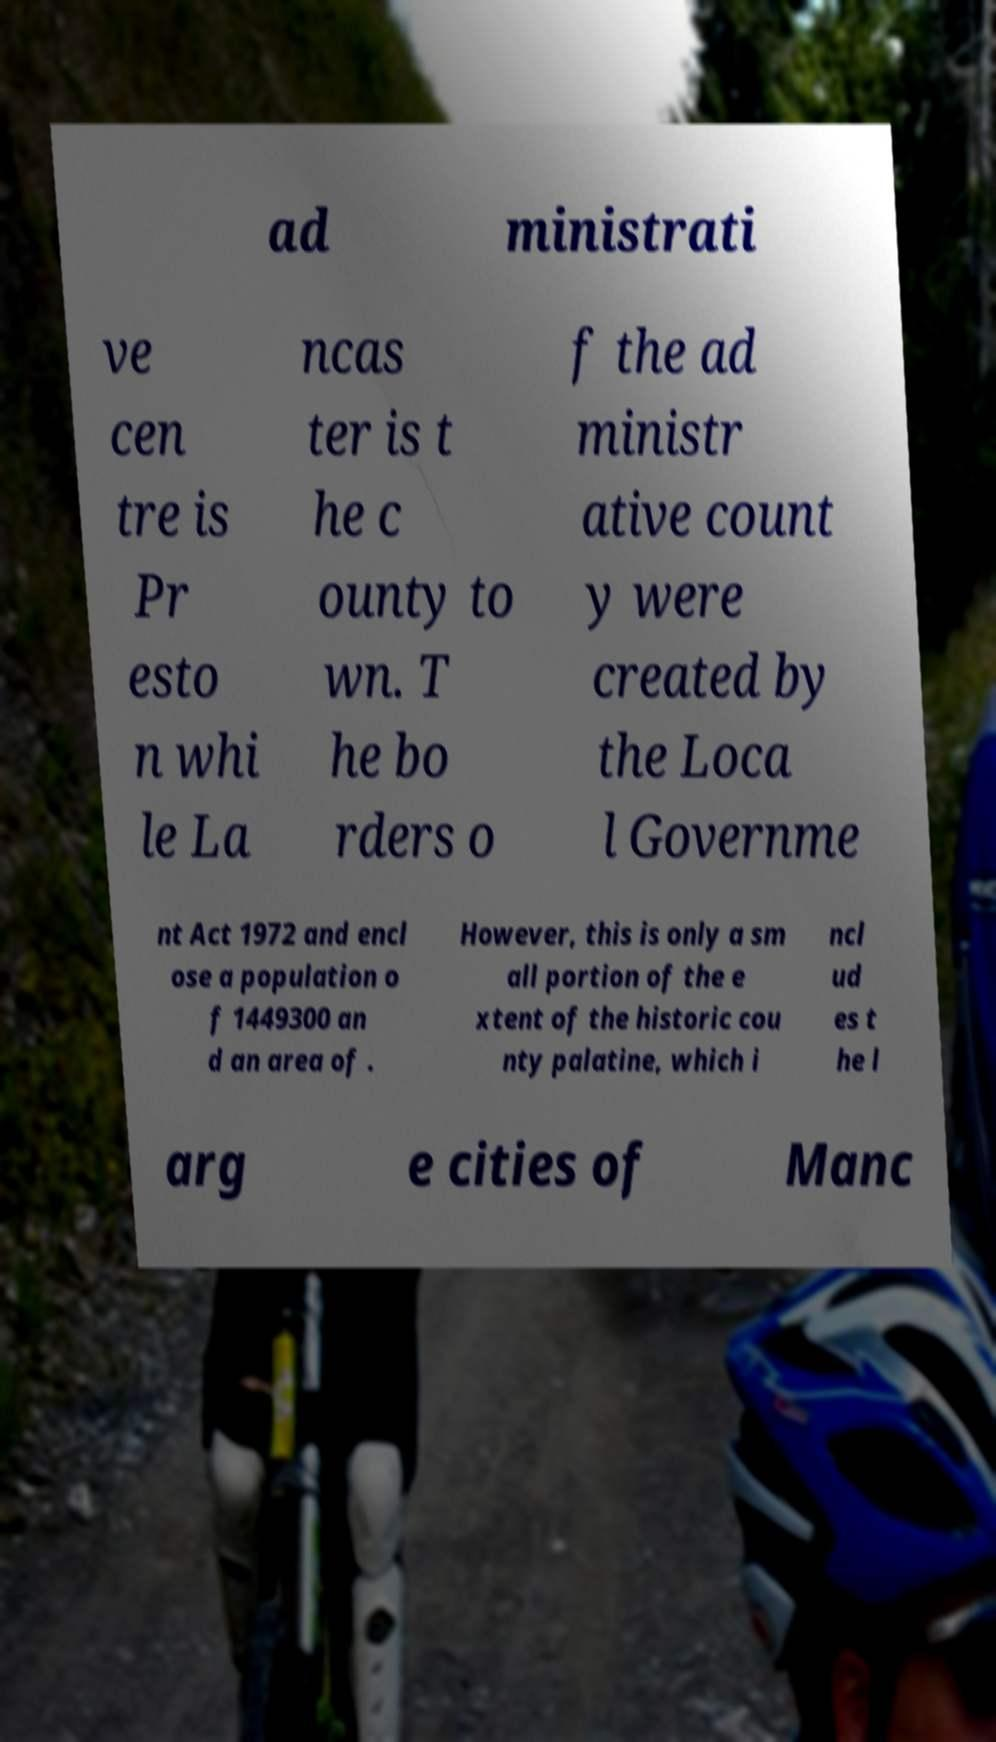Could you assist in decoding the text presented in this image and type it out clearly? ad ministrati ve cen tre is Pr esto n whi le La ncas ter is t he c ounty to wn. T he bo rders o f the ad ministr ative count y were created by the Loca l Governme nt Act 1972 and encl ose a population o f 1449300 an d an area of . However, this is only a sm all portion of the e xtent of the historic cou nty palatine, which i ncl ud es t he l arg e cities of Manc 